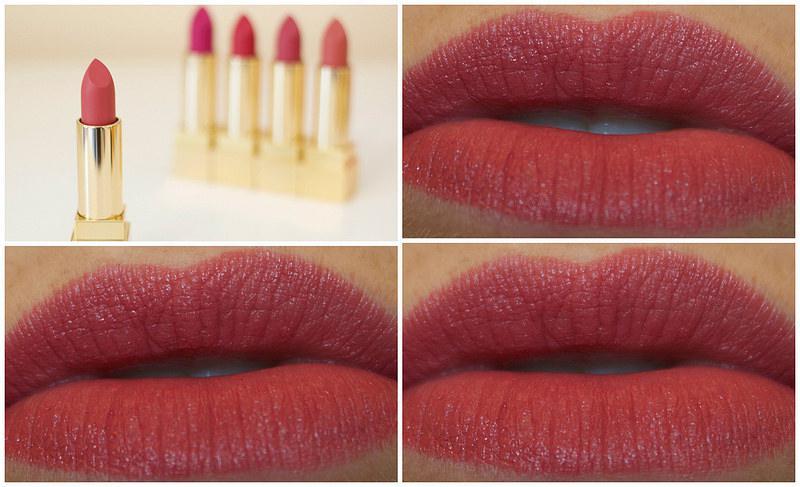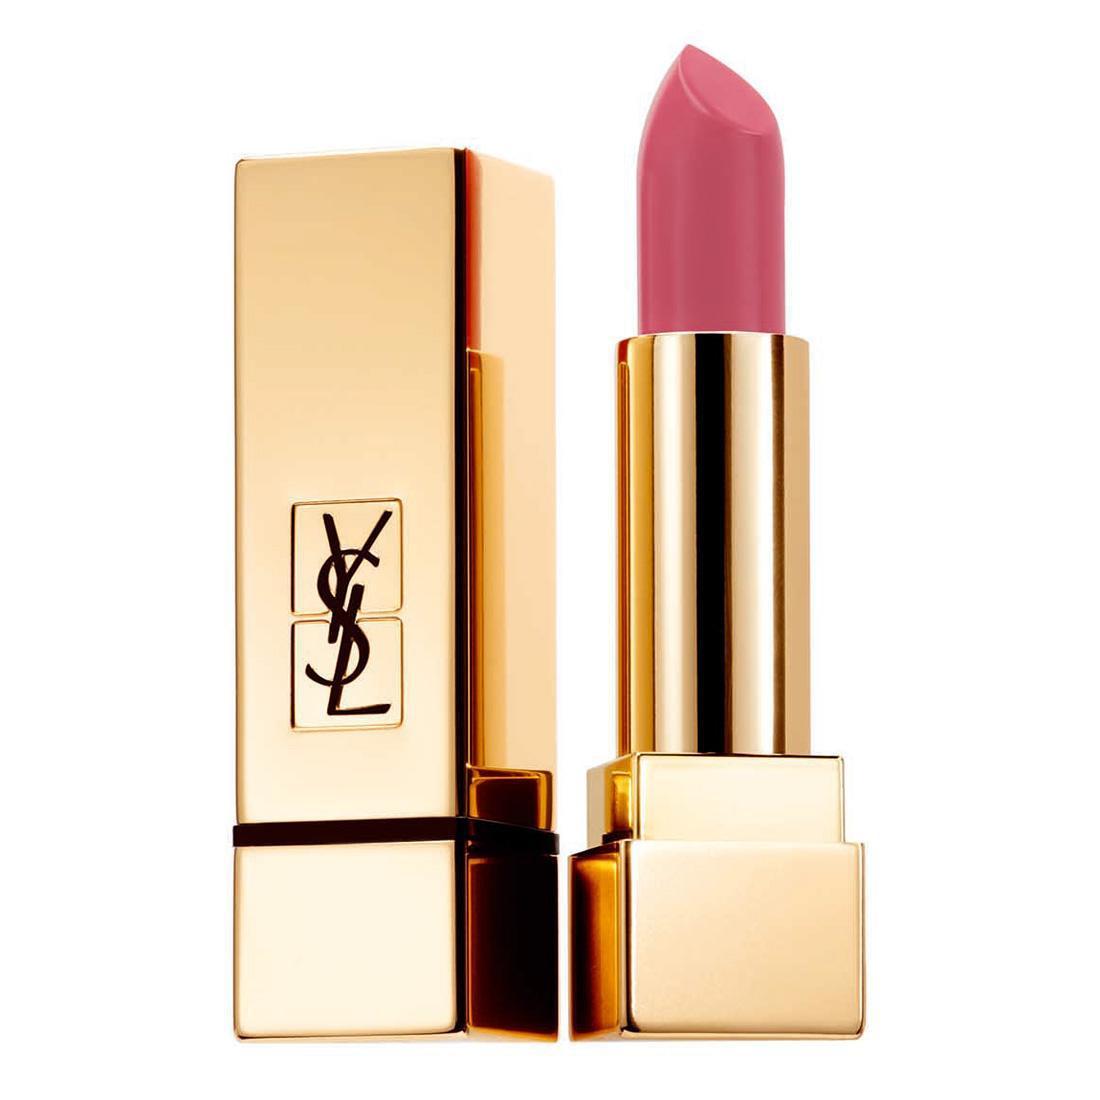The first image is the image on the left, the second image is the image on the right. For the images shown, is this caption "One image features a row of five uncapped tube lipsticks, and the other image shows an inner arm with five lipstick marks." true? Answer yes or no. No. The first image is the image on the left, the second image is the image on the right. Examine the images to the left and right. Is the description "The right image contains a human arm with several different shades of lipstick drawn on it." accurate? Answer yes or no. No. 